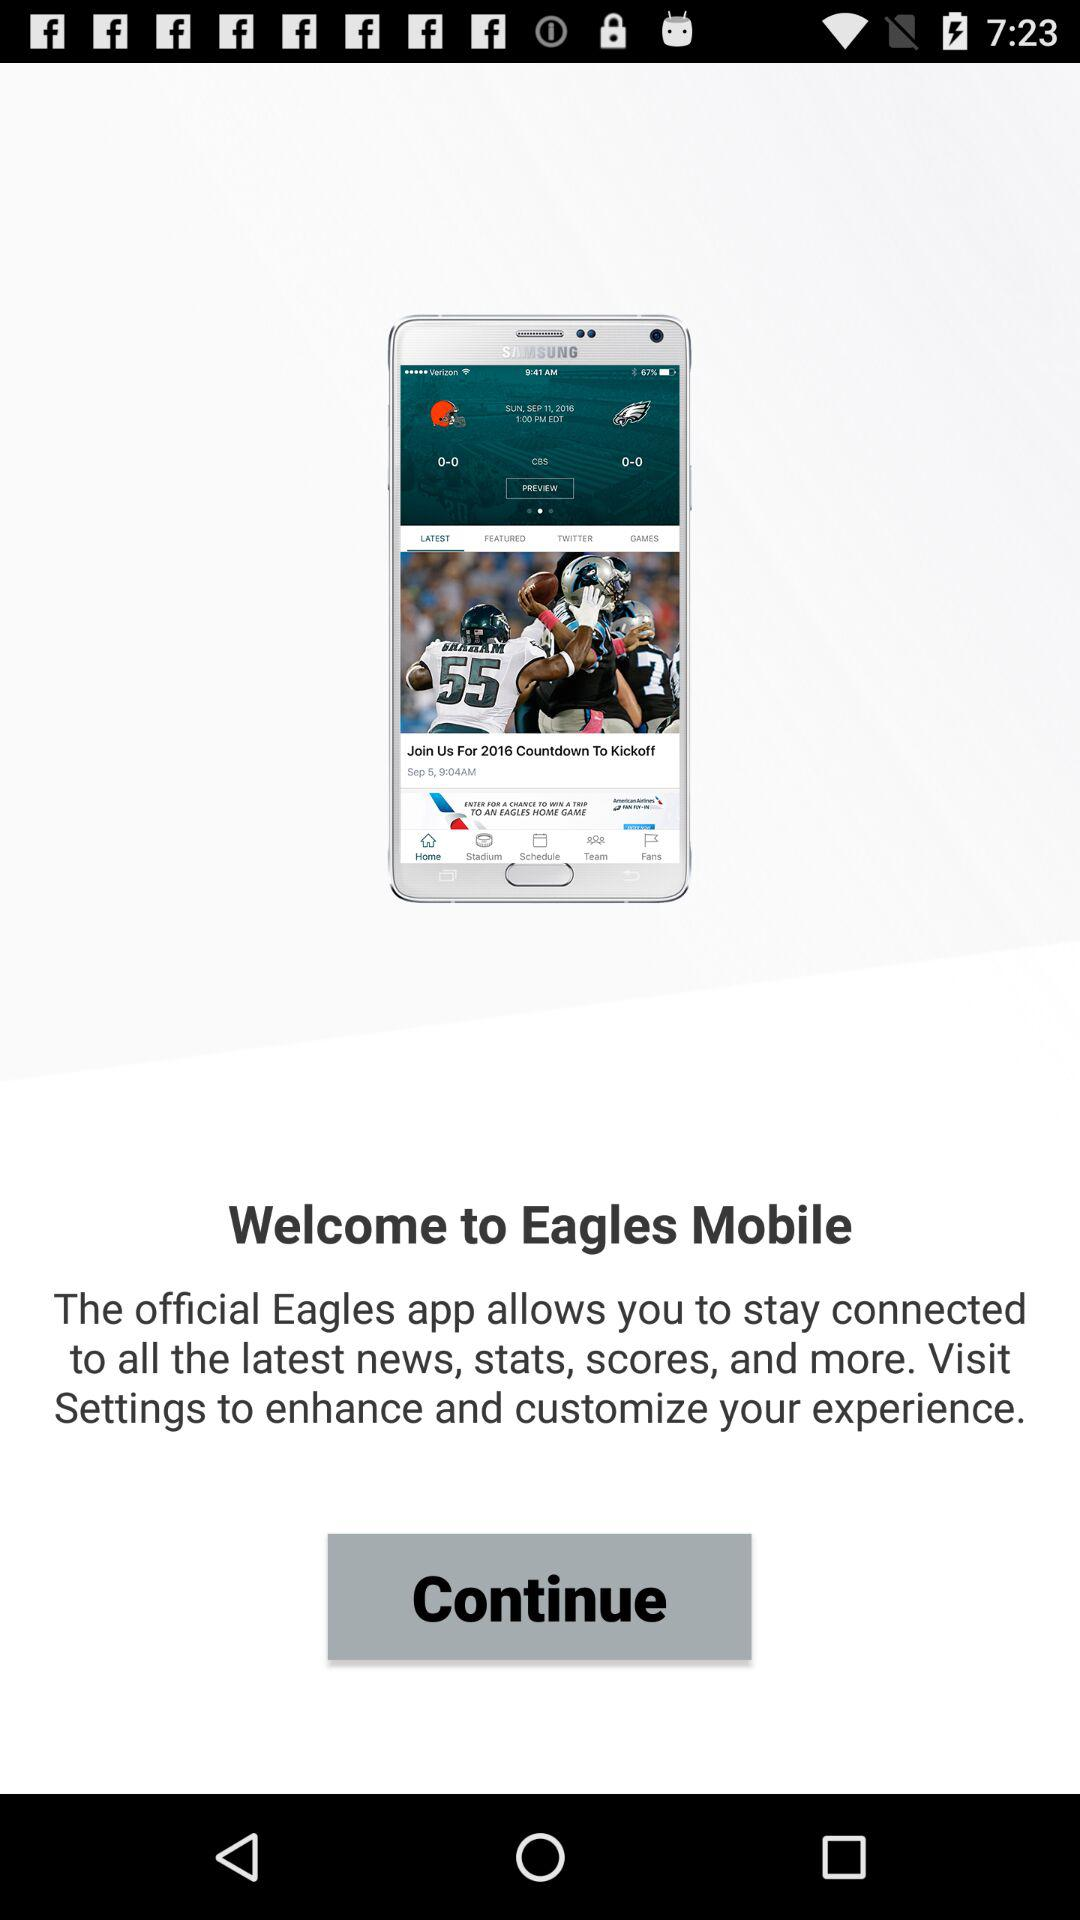What is the name of the application? The name of the application is "Eagles". 